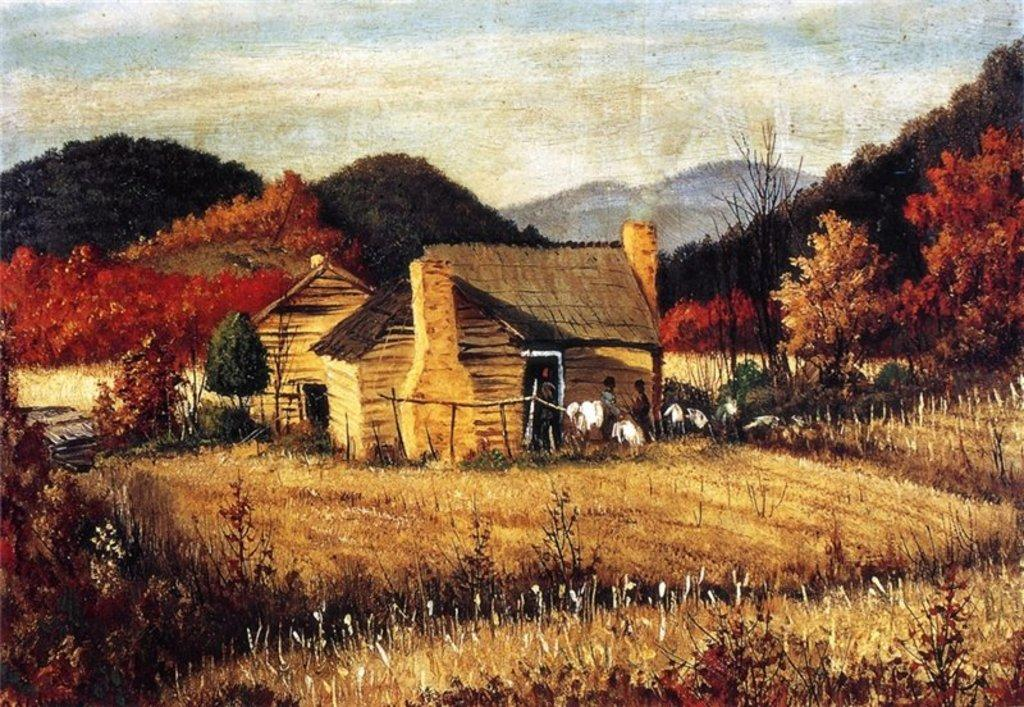What type of artwork is depicted in the image? The image is a painting. What can be seen in the middle of the painting? There are huts in the middle of the painting. Are there any people in the painting? Yes, there are persons in the painting. What type of vegetation is visible at the back of the painting? There are trees at the back side of the painting. What is visible at the top of the painting? The sky is visible at the top of the painting. Can you tell me how many stitches are used to create the huts in the painting? The painting is not a physical object, so it does not have stitches. The huts are depicted as part of the painted scene. What type of coastline can be seen in the painting? There is no coastline visible in the painting; it features huts, persons, trees, and a sky. 